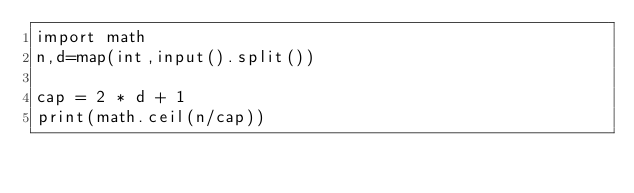<code> <loc_0><loc_0><loc_500><loc_500><_Python_>import math
n,d=map(int,input().split())

cap = 2 * d + 1
print(math.ceil(n/cap))</code> 